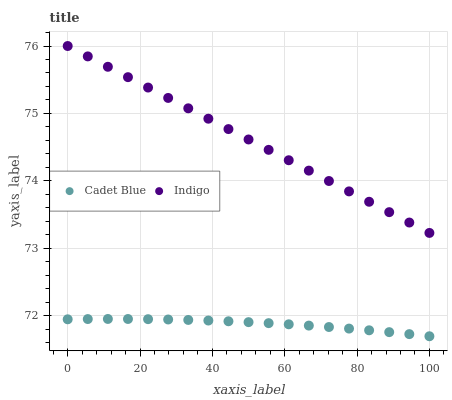Does Cadet Blue have the minimum area under the curve?
Answer yes or no. Yes. Does Indigo have the maximum area under the curve?
Answer yes or no. Yes. Does Indigo have the minimum area under the curve?
Answer yes or no. No. Is Indigo the smoothest?
Answer yes or no. Yes. Is Cadet Blue the roughest?
Answer yes or no. Yes. Is Indigo the roughest?
Answer yes or no. No. Does Cadet Blue have the lowest value?
Answer yes or no. Yes. Does Indigo have the lowest value?
Answer yes or no. No. Does Indigo have the highest value?
Answer yes or no. Yes. Is Cadet Blue less than Indigo?
Answer yes or no. Yes. Is Indigo greater than Cadet Blue?
Answer yes or no. Yes. Does Cadet Blue intersect Indigo?
Answer yes or no. No. 